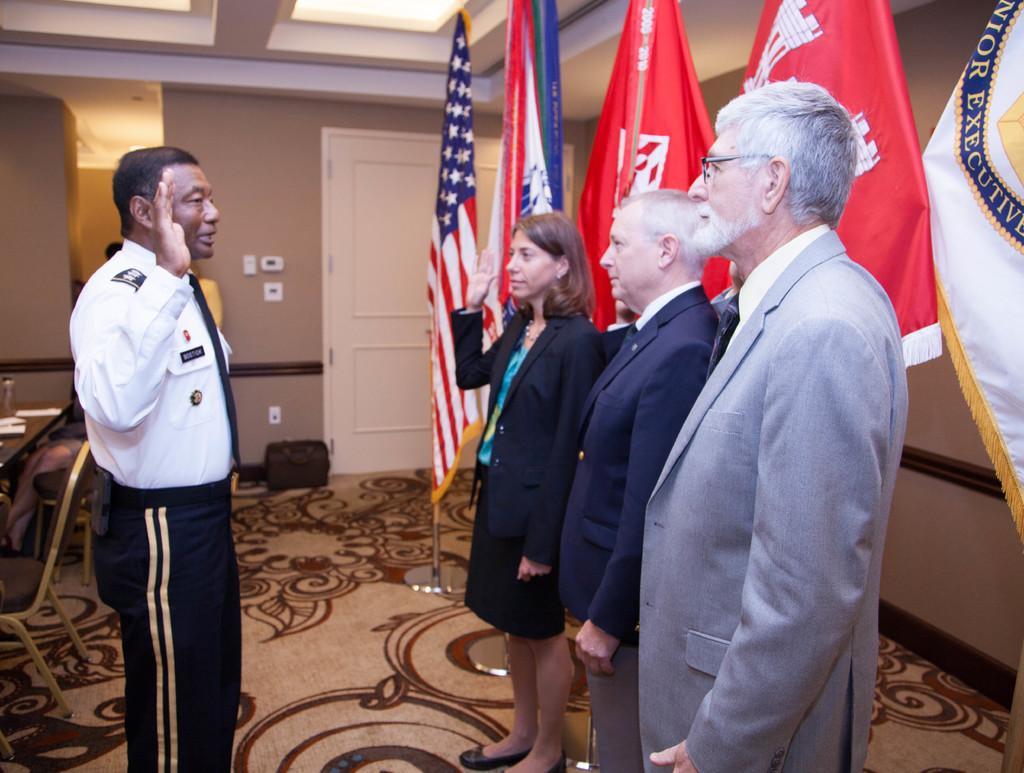Describe this image in one or two sentences. In this image I can see the group of people with different colored dressers. To the right I can see the flags. To the left I can see the table and chairs. In the background I can see the door. 